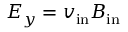<formula> <loc_0><loc_0><loc_500><loc_500>E _ { y } = v _ { i n } B _ { i n }</formula> 